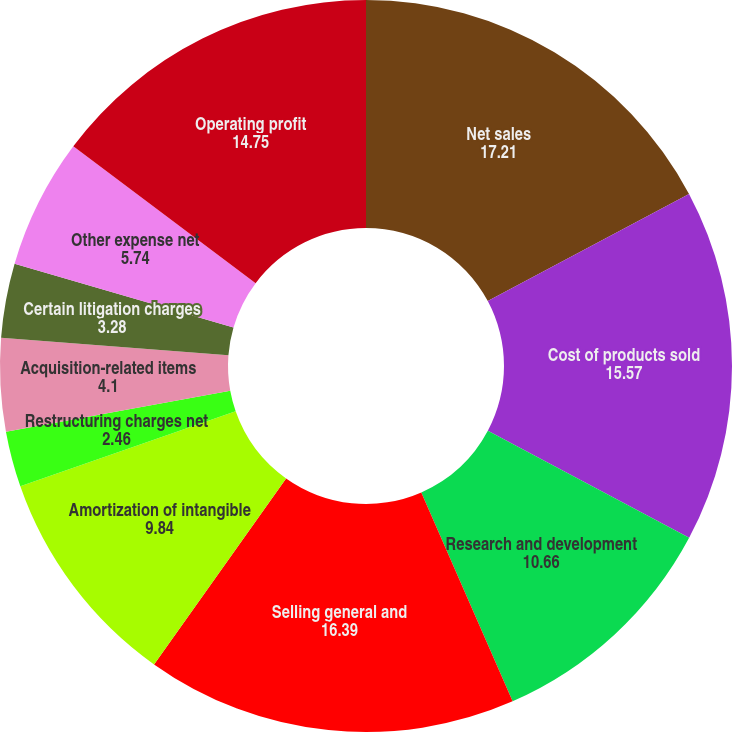Convert chart to OTSL. <chart><loc_0><loc_0><loc_500><loc_500><pie_chart><fcel>Net sales<fcel>Cost of products sold<fcel>Research and development<fcel>Selling general and<fcel>Amortization of intangible<fcel>Restructuring charges net<fcel>Acquisition-related items<fcel>Certain litigation charges<fcel>Other expense net<fcel>Operating profit<nl><fcel>17.21%<fcel>15.57%<fcel>10.66%<fcel>16.39%<fcel>9.84%<fcel>2.46%<fcel>4.1%<fcel>3.28%<fcel>5.74%<fcel>14.75%<nl></chart> 